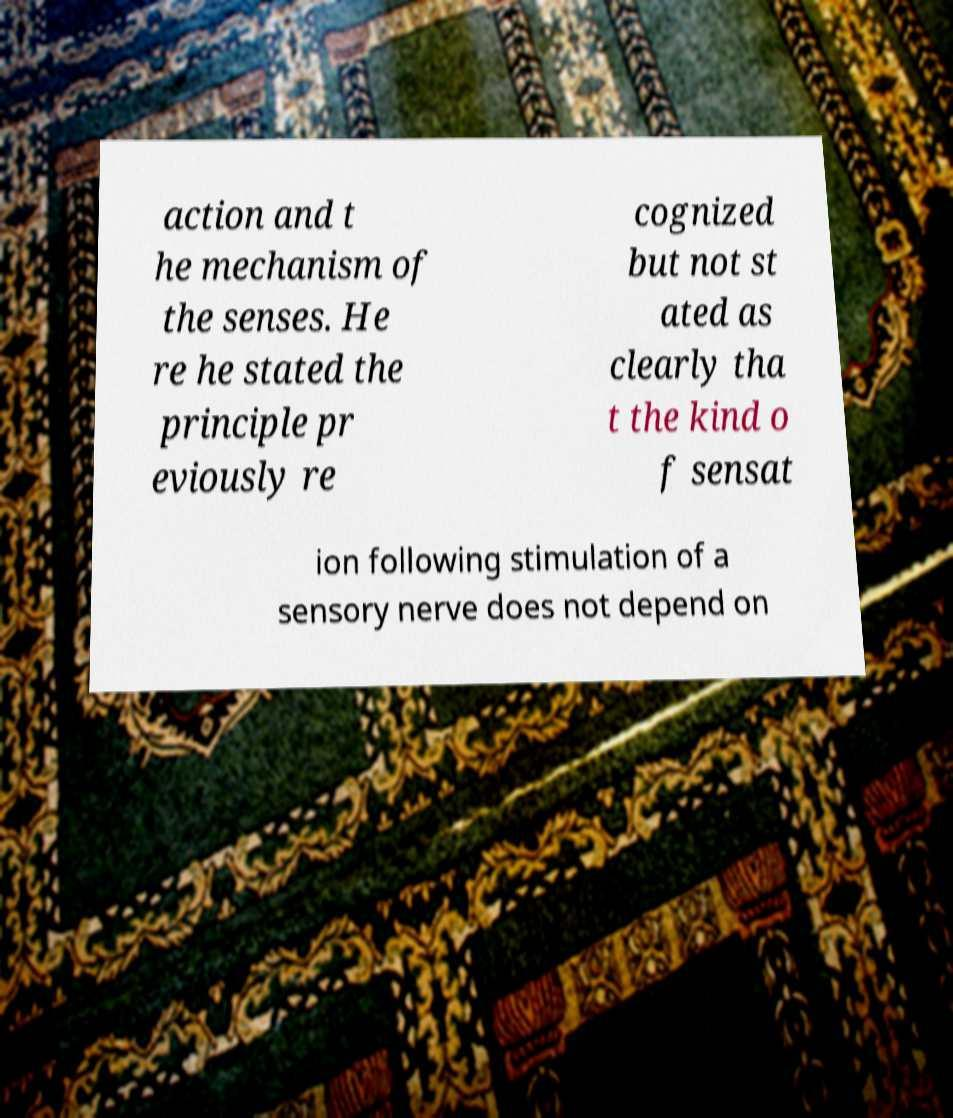Could you assist in decoding the text presented in this image and type it out clearly? action and t he mechanism of the senses. He re he stated the principle pr eviously re cognized but not st ated as clearly tha t the kind o f sensat ion following stimulation of a sensory nerve does not depend on 